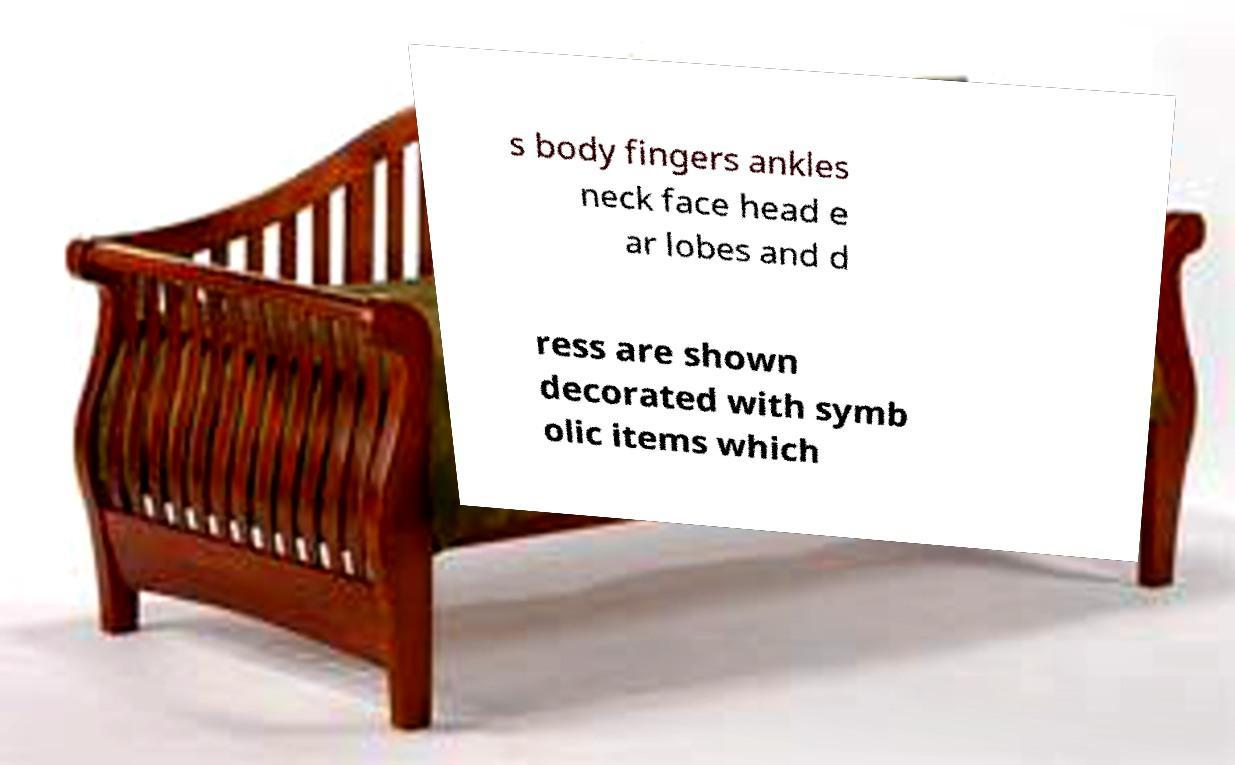For documentation purposes, I need the text within this image transcribed. Could you provide that? s body fingers ankles neck face head e ar lobes and d ress are shown decorated with symb olic items which 